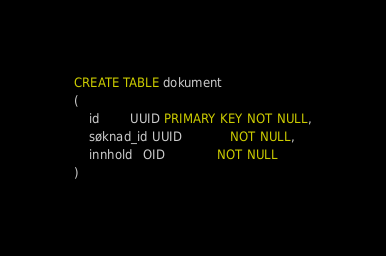<code> <loc_0><loc_0><loc_500><loc_500><_SQL_>CREATE TABLE dokument
(
    id        UUID PRIMARY KEY NOT NULL,
    søknad_id UUID             NOT NULL,
    innhold   OID              NOT NULL
)
</code> 